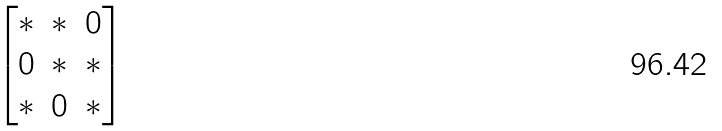<formula> <loc_0><loc_0><loc_500><loc_500>\begin{bmatrix} * & * & 0 \\ 0 & * & * \\ * & 0 & * \end{bmatrix}</formula> 